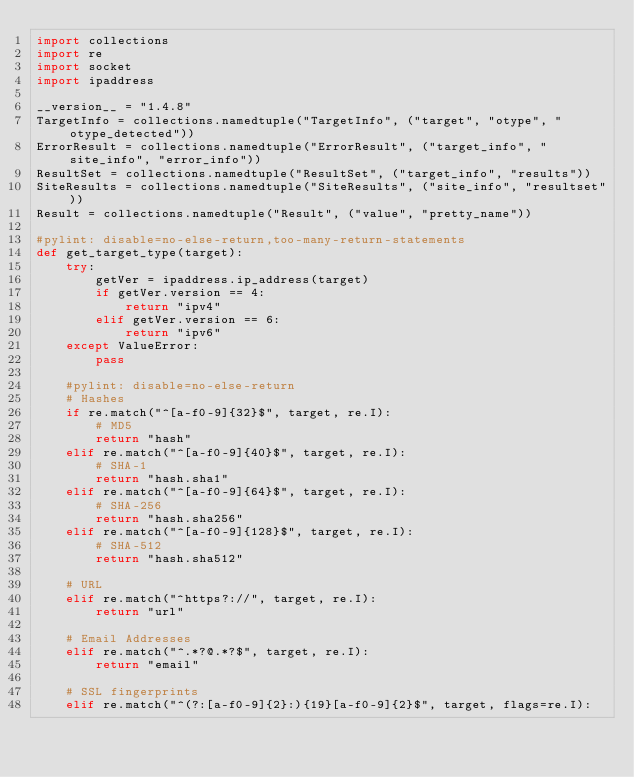<code> <loc_0><loc_0><loc_500><loc_500><_Python_>import collections
import re
import socket
import ipaddress

__version__ = "1.4.8"
TargetInfo = collections.namedtuple("TargetInfo", ("target", "otype", "otype_detected"))
ErrorResult = collections.namedtuple("ErrorResult", ("target_info", "site_info", "error_info"))
ResultSet = collections.namedtuple("ResultSet", ("target_info", "results"))
SiteResults = collections.namedtuple("SiteResults", ("site_info", "resultset"))
Result = collections.namedtuple("Result", ("value", "pretty_name"))

#pylint: disable=no-else-return,too-many-return-statements
def get_target_type(target):
    try:
        getVer = ipaddress.ip_address(target)
        if getVer.version == 4:
            return "ipv4"
        elif getVer.version == 6:
            return "ipv6"
    except ValueError:
        pass

    #pylint: disable=no-else-return
    # Hashes
    if re.match("^[a-f0-9]{32}$", target, re.I):
        # MD5
        return "hash"
    elif re.match("^[a-f0-9]{40}$", target, re.I):
        # SHA-1
        return "hash.sha1"
    elif re.match("^[a-f0-9]{64}$", target, re.I):
        # SHA-256
        return "hash.sha256"
    elif re.match("^[a-f0-9]{128}$", target, re.I):
        # SHA-512
        return "hash.sha512"

    # URL
    elif re.match("^https?://", target, re.I):
        return "url"

    # Email Addresses
    elif re.match("^.*?@.*?$", target, re.I):
        return "email"

    # SSL fingerprints
    elif re.match("^(?:[a-f0-9]{2}:){19}[a-f0-9]{2}$", target, flags=re.I):</code> 